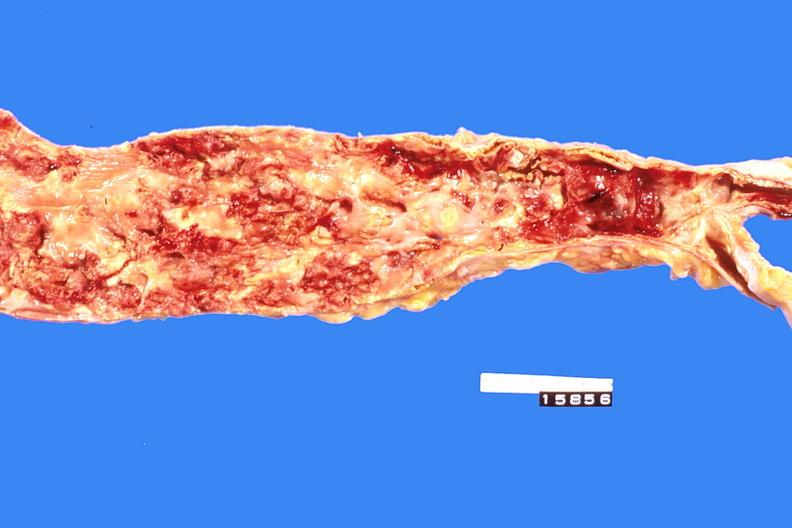what does this image show?
Answer the question using a single word or phrase. Abdominal aorta 